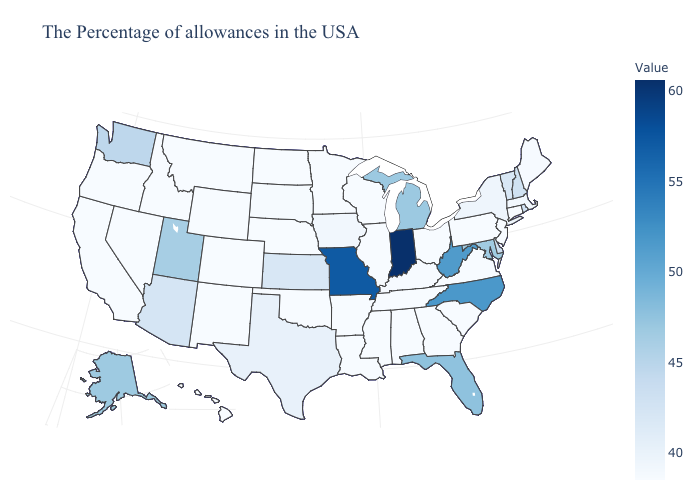Does North Carolina have the lowest value in the South?
Answer briefly. No. Does Maine have the lowest value in the Northeast?
Quick response, please. No. Among the states that border Alabama , does Florida have the highest value?
Short answer required. Yes. Does Florida have the lowest value in the South?
Write a very short answer. No. Which states have the lowest value in the USA?
Give a very brief answer. Connecticut, New Jersey, Pennsylvania, Virginia, South Carolina, Ohio, Georgia, Alabama, Tennessee, Wisconsin, Illinois, Mississippi, Louisiana, Arkansas, Minnesota, Nebraska, Oklahoma, North Dakota, Wyoming, Colorado, New Mexico, Montana, Idaho, Nevada, California, Oregon, Hawaii. 